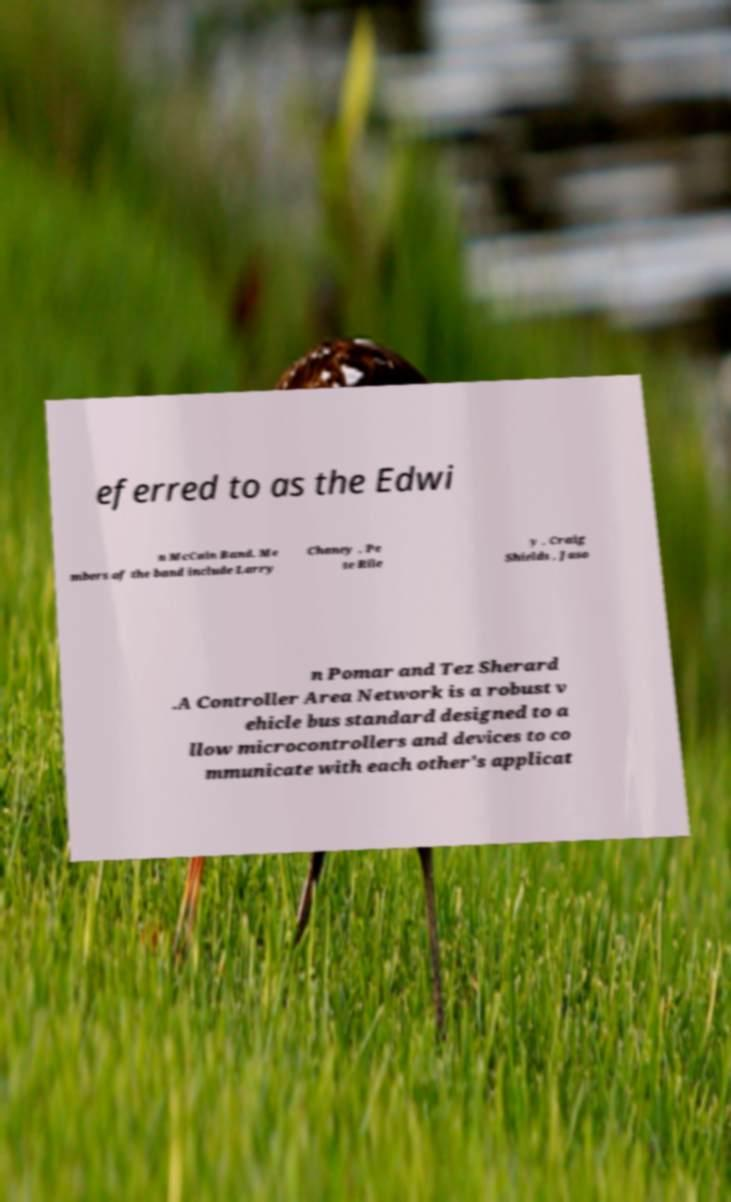Please read and relay the text visible in this image. What does it say? eferred to as the Edwi n McCain Band. Me mbers of the band include Larry Chaney , Pe te Rile y , Craig Shields , Jaso n Pomar and Tez Sherard .A Controller Area Network is a robust v ehicle bus standard designed to a llow microcontrollers and devices to co mmunicate with each other's applicat 